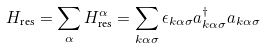Convert formula to latex. <formula><loc_0><loc_0><loc_500><loc_500>H _ { \text {res} } = \sum _ { \alpha } H _ { \text {res} } ^ { \alpha } = \sum _ { k \alpha \sigma } \epsilon _ { k \alpha \sigma } a ^ { \dagger } _ { k \alpha \sigma } a _ { k \alpha \sigma }</formula> 